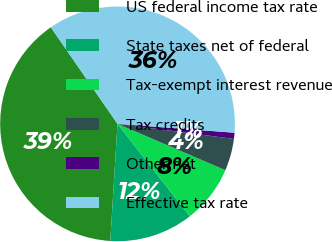<chart> <loc_0><loc_0><loc_500><loc_500><pie_chart><fcel>US federal income tax rate<fcel>State taxes net of federal<fcel>Tax-exempt interest revenue<fcel>Tax credits<fcel>Other net<fcel>Effective tax rate<nl><fcel>39.4%<fcel>11.55%<fcel>7.98%<fcel>4.41%<fcel>0.84%<fcel>35.83%<nl></chart> 